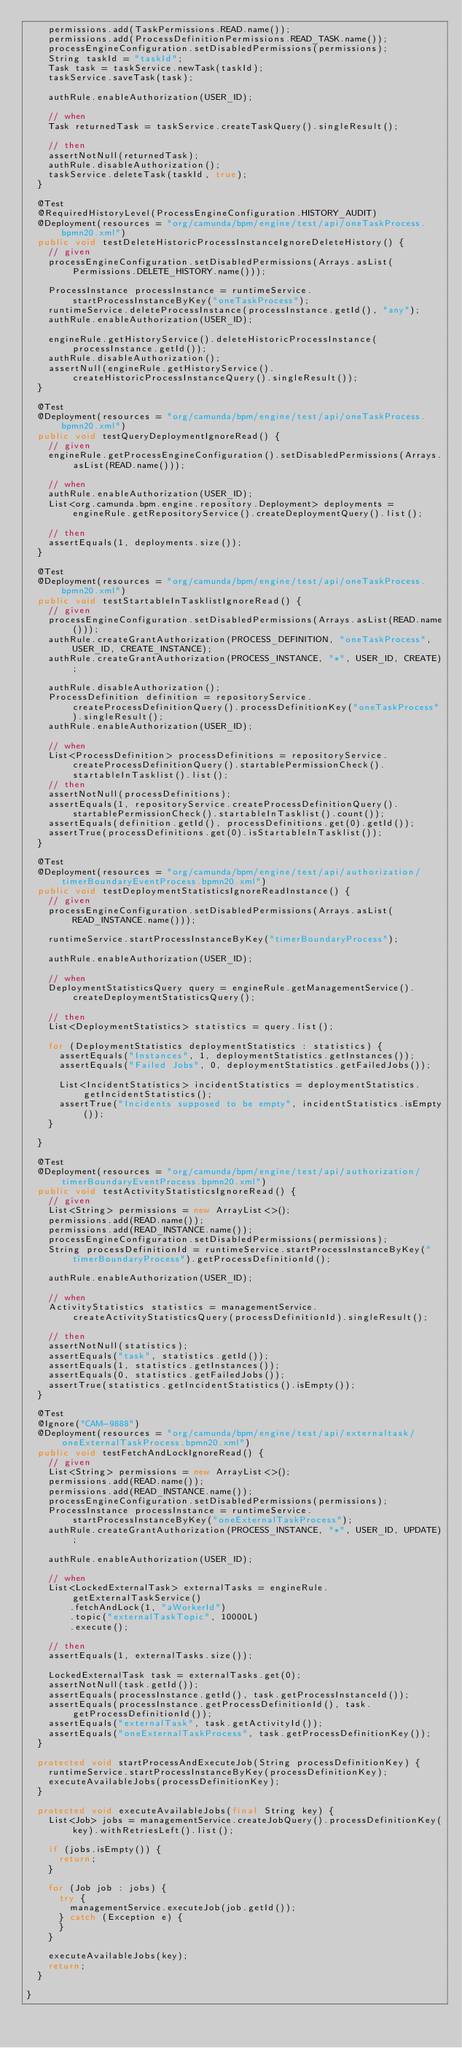Convert code to text. <code><loc_0><loc_0><loc_500><loc_500><_Java_>    permissions.add(TaskPermissions.READ.name());
    permissions.add(ProcessDefinitionPermissions.READ_TASK.name());
    processEngineConfiguration.setDisabledPermissions(permissions);
    String taskId = "taskId";
    Task task = taskService.newTask(taskId);
    taskService.saveTask(task);

    authRule.enableAuthorization(USER_ID);

    // when
    Task returnedTask = taskService.createTaskQuery().singleResult();

    // then
    assertNotNull(returnedTask);
    authRule.disableAuthorization();
    taskService.deleteTask(taskId, true);
  }

  @Test
  @RequiredHistoryLevel(ProcessEngineConfiguration.HISTORY_AUDIT)
  @Deployment(resources = "org/camunda/bpm/engine/test/api/oneTaskProcess.bpmn20.xml")
  public void testDeleteHistoricProcessInstanceIgnoreDeleteHistory() {
    // given
    processEngineConfiguration.setDisabledPermissions(Arrays.asList(Permissions.DELETE_HISTORY.name()));

    ProcessInstance processInstance = runtimeService.startProcessInstanceByKey("oneTaskProcess");
    runtimeService.deleteProcessInstance(processInstance.getId(), "any");
    authRule.enableAuthorization(USER_ID);

    engineRule.getHistoryService().deleteHistoricProcessInstance(processInstance.getId());
    authRule.disableAuthorization();
    assertNull(engineRule.getHistoryService().createHistoricProcessInstanceQuery().singleResult());
  }

  @Test
  @Deployment(resources = "org/camunda/bpm/engine/test/api/oneTaskProcess.bpmn20.xml")
  public void testQueryDeploymentIgnoreRead() {
    // given
    engineRule.getProcessEngineConfiguration().setDisabledPermissions(Arrays.asList(READ.name()));

    // when
    authRule.enableAuthorization(USER_ID);
    List<org.camunda.bpm.engine.repository.Deployment> deployments = engineRule.getRepositoryService().createDeploymentQuery().list();

    // then
    assertEquals(1, deployments.size());
  }

  @Test
  @Deployment(resources = "org/camunda/bpm/engine/test/api/oneTaskProcess.bpmn20.xml")
  public void testStartableInTasklistIgnoreRead() {
    // given
    processEngineConfiguration.setDisabledPermissions(Arrays.asList(READ.name()));
    authRule.createGrantAuthorization(PROCESS_DEFINITION, "oneTaskProcess", USER_ID, CREATE_INSTANCE);
    authRule.createGrantAuthorization(PROCESS_INSTANCE, "*", USER_ID, CREATE);

    authRule.disableAuthorization();
    ProcessDefinition definition = repositoryService.createProcessDefinitionQuery().processDefinitionKey("oneTaskProcess").singleResult();
    authRule.enableAuthorization(USER_ID);

    // when
    List<ProcessDefinition> processDefinitions = repositoryService.createProcessDefinitionQuery().startablePermissionCheck().startableInTasklist().list();
    // then
    assertNotNull(processDefinitions);
    assertEquals(1, repositoryService.createProcessDefinitionQuery().startablePermissionCheck().startableInTasklist().count());
    assertEquals(definition.getId(), processDefinitions.get(0).getId());
    assertTrue(processDefinitions.get(0).isStartableInTasklist());
  }

  @Test
  @Deployment(resources = "org/camunda/bpm/engine/test/api/authorization/timerBoundaryEventProcess.bpmn20.xml")
  public void testDeploymentStatisticsIgnoreReadInstance() {
    // given
    processEngineConfiguration.setDisabledPermissions(Arrays.asList(READ_INSTANCE.name()));

    runtimeService.startProcessInstanceByKey("timerBoundaryProcess");

    authRule.enableAuthorization(USER_ID);

    // when
    DeploymentStatisticsQuery query = engineRule.getManagementService().createDeploymentStatisticsQuery();

    // then
    List<DeploymentStatistics> statistics = query.list();

    for (DeploymentStatistics deploymentStatistics : statistics) {
      assertEquals("Instances", 1, deploymentStatistics.getInstances());
      assertEquals("Failed Jobs", 0, deploymentStatistics.getFailedJobs());

      List<IncidentStatistics> incidentStatistics = deploymentStatistics.getIncidentStatistics();
      assertTrue("Incidents supposed to be empty", incidentStatistics.isEmpty());
    }

  }

  @Test
  @Deployment(resources = "org/camunda/bpm/engine/test/api/authorization/timerBoundaryEventProcess.bpmn20.xml")
  public void testActivityStatisticsIgnoreRead() {
    // given
    List<String> permissions = new ArrayList<>();
    permissions.add(READ.name());
    permissions.add(READ_INSTANCE.name());
    processEngineConfiguration.setDisabledPermissions(permissions);
    String processDefinitionId = runtimeService.startProcessInstanceByKey("timerBoundaryProcess").getProcessDefinitionId();

    authRule.enableAuthorization(USER_ID);

    // when
    ActivityStatistics statistics = managementService.createActivityStatisticsQuery(processDefinitionId).singleResult();

    // then
    assertNotNull(statistics);
    assertEquals("task", statistics.getId());
    assertEquals(1, statistics.getInstances());
    assertEquals(0, statistics.getFailedJobs());
    assertTrue(statistics.getIncidentStatistics().isEmpty());
  }

  @Test
  @Ignore("CAM-9888")
  @Deployment(resources = "org/camunda/bpm/engine/test/api/externaltask/oneExternalTaskProcess.bpmn20.xml")
  public void testFetchAndLockIgnoreRead() {
    // given
    List<String> permissions = new ArrayList<>();
    permissions.add(READ.name());
    permissions.add(READ_INSTANCE.name());
    processEngineConfiguration.setDisabledPermissions(permissions);
    ProcessInstance processInstance = runtimeService.startProcessInstanceByKey("oneExternalTaskProcess");
    authRule.createGrantAuthorization(PROCESS_INSTANCE, "*", USER_ID, UPDATE);

    authRule.enableAuthorization(USER_ID);

    // when
    List<LockedExternalTask> externalTasks = engineRule.getExternalTaskService()
        .fetchAndLock(1, "aWorkerId")
        .topic("externalTaskTopic", 10000L)
        .execute();

    // then
    assertEquals(1, externalTasks.size());

    LockedExternalTask task = externalTasks.get(0);
    assertNotNull(task.getId());
    assertEquals(processInstance.getId(), task.getProcessInstanceId());
    assertEquals(processInstance.getProcessDefinitionId(), task.getProcessDefinitionId());
    assertEquals("externalTask", task.getActivityId());
    assertEquals("oneExternalTaskProcess", task.getProcessDefinitionKey());
  }

  protected void startProcessAndExecuteJob(String processDefinitionKey) {
    runtimeService.startProcessInstanceByKey(processDefinitionKey);
    executeAvailableJobs(processDefinitionKey);
  }

  protected void executeAvailableJobs(final String key) {
    List<Job> jobs = managementService.createJobQuery().processDefinitionKey(key).withRetriesLeft().list();

    if (jobs.isEmpty()) {
      return;
    }

    for (Job job : jobs) {
      try {
        managementService.executeJob(job.getId());
      } catch (Exception e) {
      }
    }

    executeAvailableJobs(key);
    return;
  }

}
</code> 